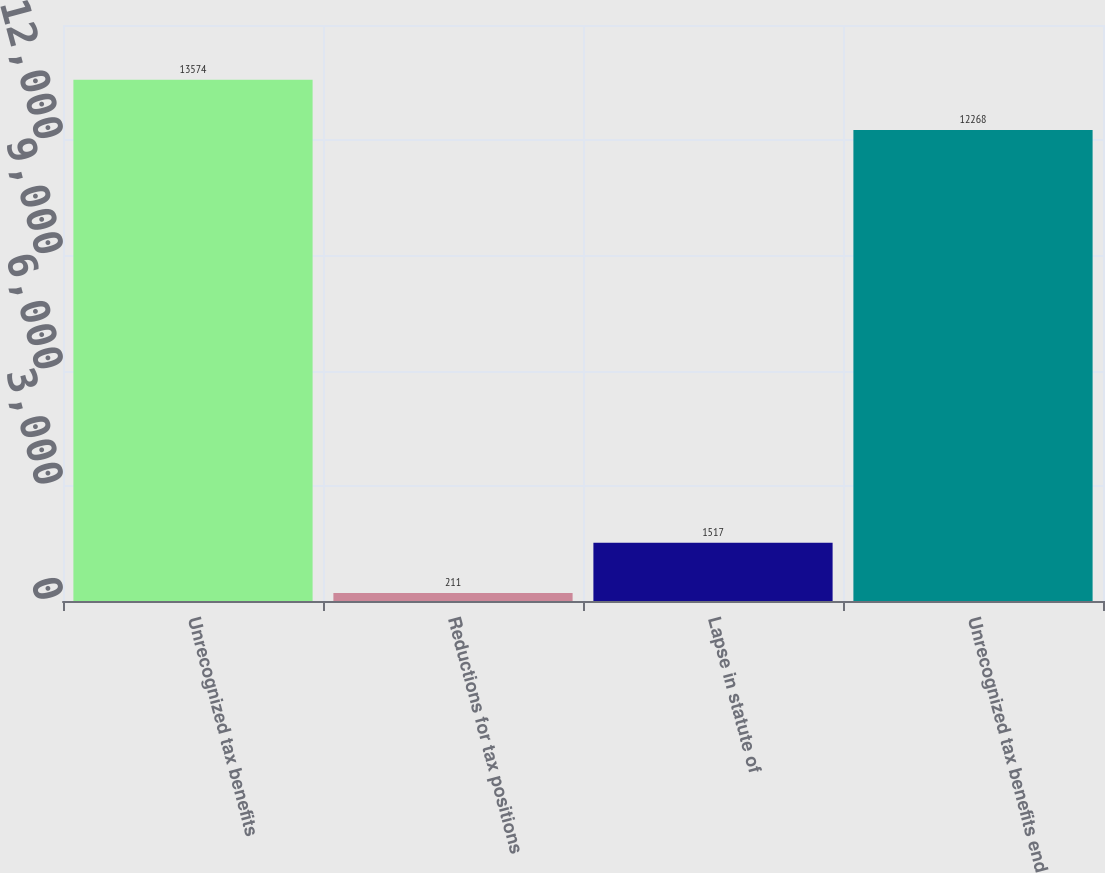<chart> <loc_0><loc_0><loc_500><loc_500><bar_chart><fcel>Unrecognized tax benefits<fcel>Reductions for tax positions<fcel>Lapse in statute of<fcel>Unrecognized tax benefits end<nl><fcel>13574<fcel>211<fcel>1517<fcel>12268<nl></chart> 